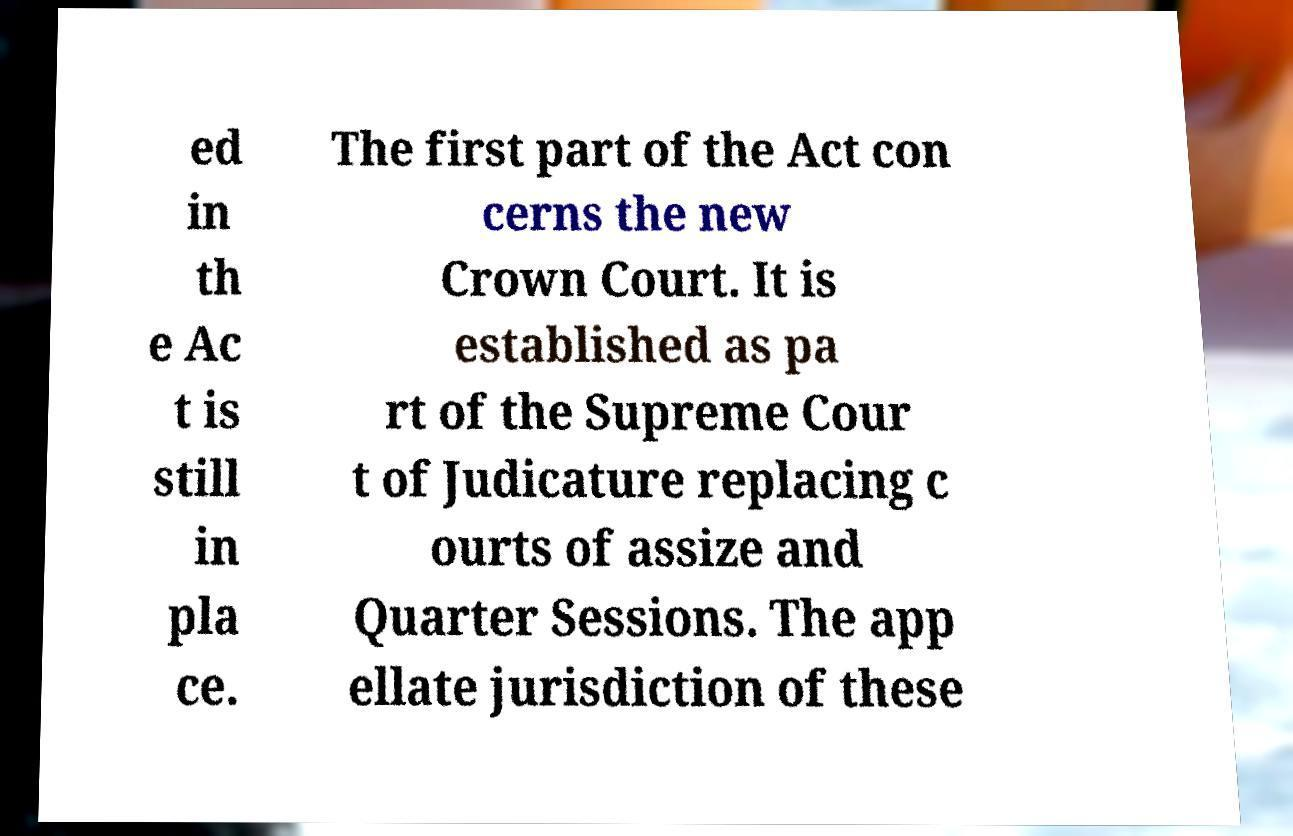Could you extract and type out the text from this image? ed in th e Ac t is still in pla ce. The first part of the Act con cerns the new Crown Court. It is established as pa rt of the Supreme Cour t of Judicature replacing c ourts of assize and Quarter Sessions. The app ellate jurisdiction of these 